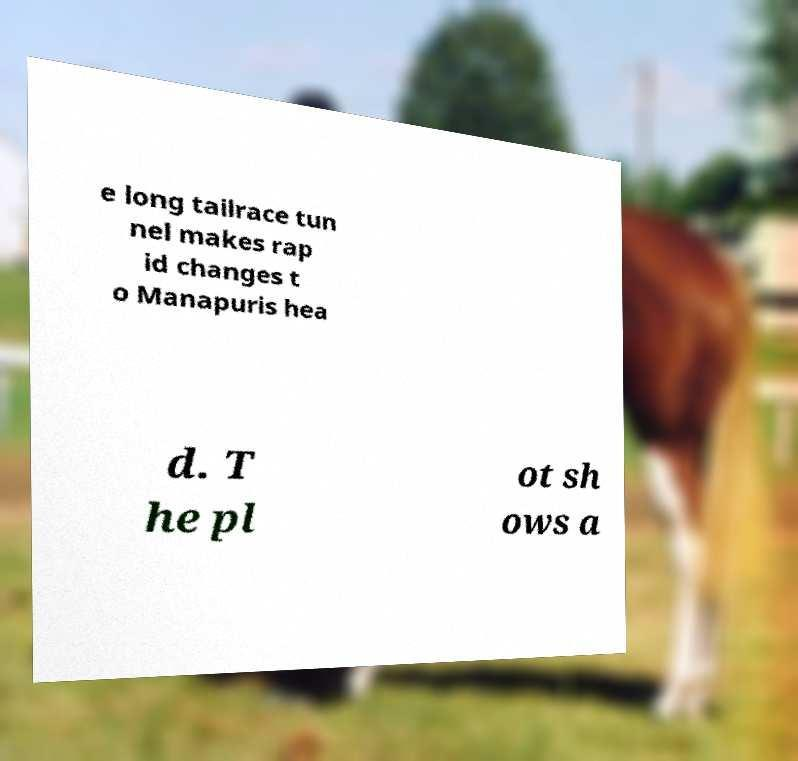For documentation purposes, I need the text within this image transcribed. Could you provide that? e long tailrace tun nel makes rap id changes t o Manapuris hea d. T he pl ot sh ows a 